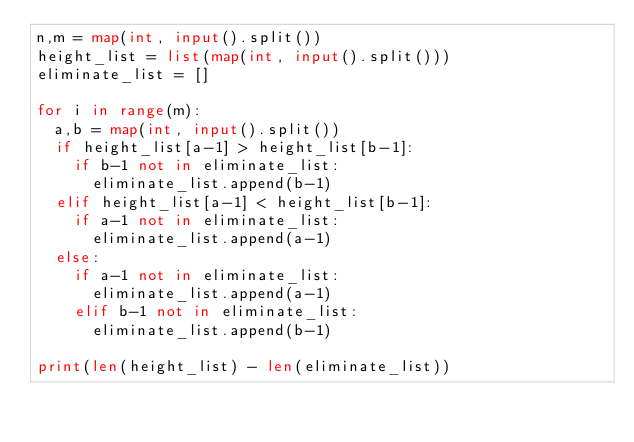Convert code to text. <code><loc_0><loc_0><loc_500><loc_500><_Python_>n,m = map(int, input().split())
height_list = list(map(int, input().split()))
eliminate_list = []

for i in range(m):
  a,b = map(int, input().split())
  if height_list[a-1] > height_list[b-1]:
    if b-1 not in eliminate_list:
      eliminate_list.append(b-1)
  elif height_list[a-1] < height_list[b-1]:
    if a-1 not in eliminate_list:
      eliminate_list.append(a-1)
  else:
    if a-1 not in eliminate_list:
      eliminate_list.append(a-1)
    elif b-1 not in eliminate_list:  
      eliminate_list.append(b-1)

print(len(height_list) - len(eliminate_list))    </code> 